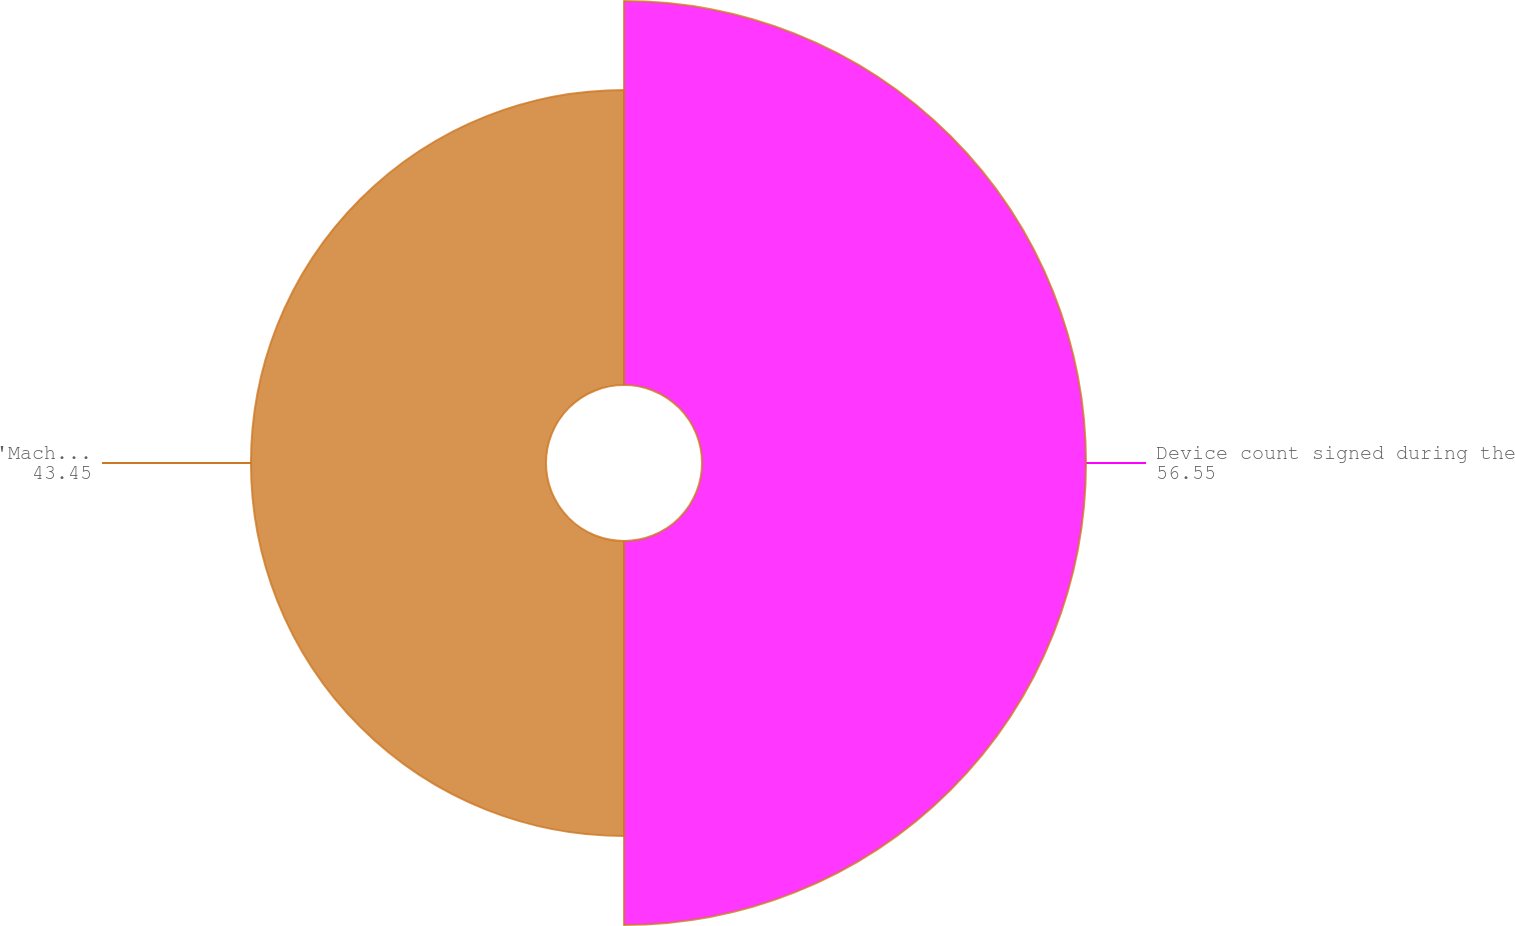Convert chart. <chart><loc_0><loc_0><loc_500><loc_500><pie_chart><fcel>Device count signed during the<fcel>'Machine equivalent' count<nl><fcel>56.55%<fcel>43.45%<nl></chart> 